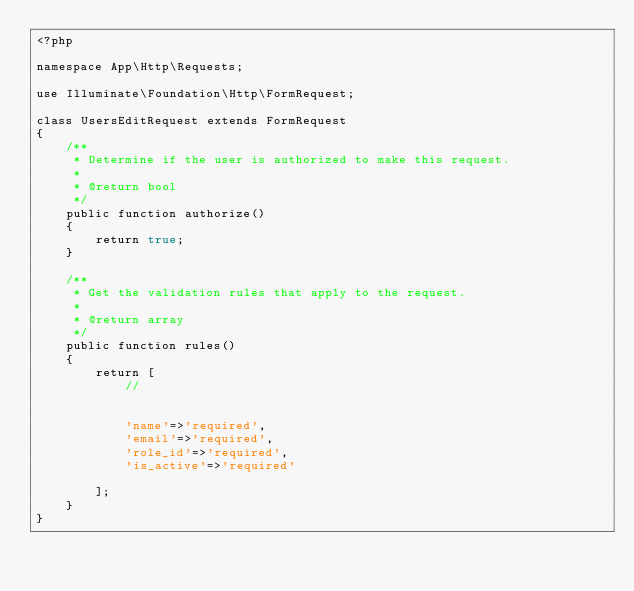Convert code to text. <code><loc_0><loc_0><loc_500><loc_500><_PHP_><?php

namespace App\Http\Requests;

use Illuminate\Foundation\Http\FormRequest;

class UsersEditRequest extends FormRequest
{
    /**
     * Determine if the user is authorized to make this request.
     *
     * @return bool
     */
    public function authorize()
    {
        return true;
    }

    /**
     * Get the validation rules that apply to the request.
     *
     * @return array
     */
    public function rules()
    {
        return [
            //


            'name'=>'required',
            'email'=>'required',
            'role_id'=>'required',
            'is_active'=>'required'
                    
        ];
    }
}
</code> 